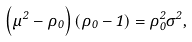Convert formula to latex. <formula><loc_0><loc_0><loc_500><loc_500>\left ( \mu ^ { 2 } - \rho _ { 0 } \right ) \left ( \rho _ { 0 } - 1 \right ) = \rho _ { 0 } ^ { 2 } \sigma ^ { 2 } ,</formula> 